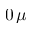Convert formula to latex. <formula><loc_0><loc_0><loc_500><loc_500>0 \, \mu</formula> 